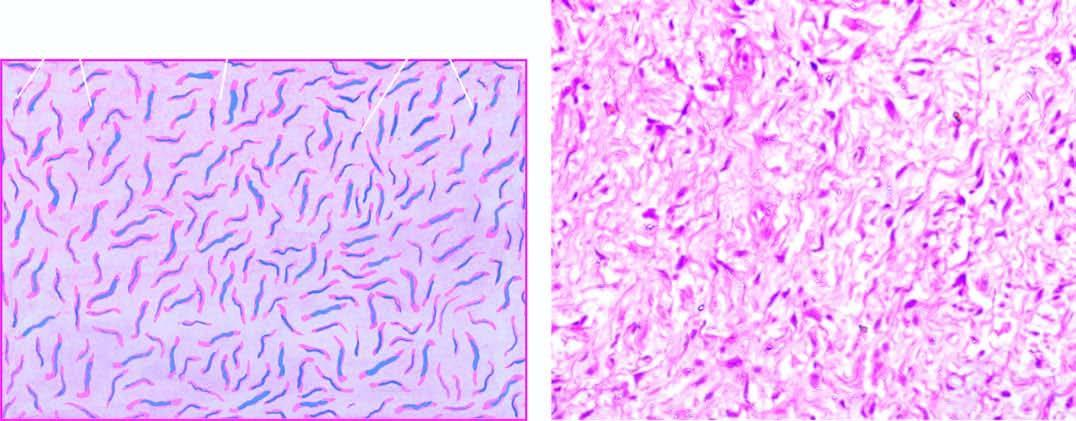does neurofibroma show interlacing bundles of spindle-shaped cells separate by mucoid matrix?
Answer the question using a single word or phrase. Yes 